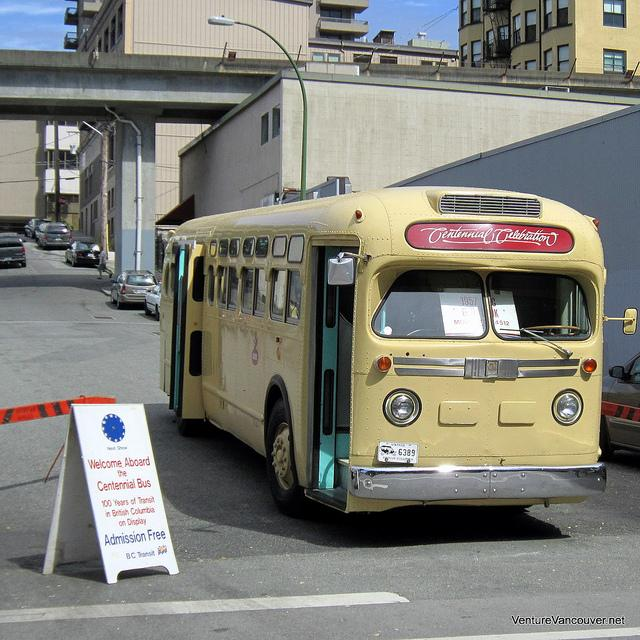This bus is part of what? centennial celebration 